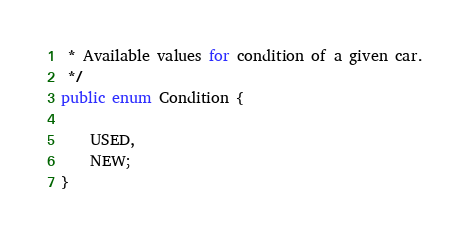Convert code to text. <code><loc_0><loc_0><loc_500><loc_500><_Java_> * Available values for condition of a given car.
 */
public enum Condition {

    USED,
    NEW;
}</code> 